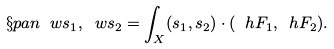<formula> <loc_0><loc_0><loc_500><loc_500>\S p a n { \ w s _ { 1 } , \ w s _ { 2 } } = \int _ { X } ( s _ { 1 } , s _ { 2 } ) \cdot ( \ h F _ { 1 } , \ h F _ { 2 } ) .</formula> 